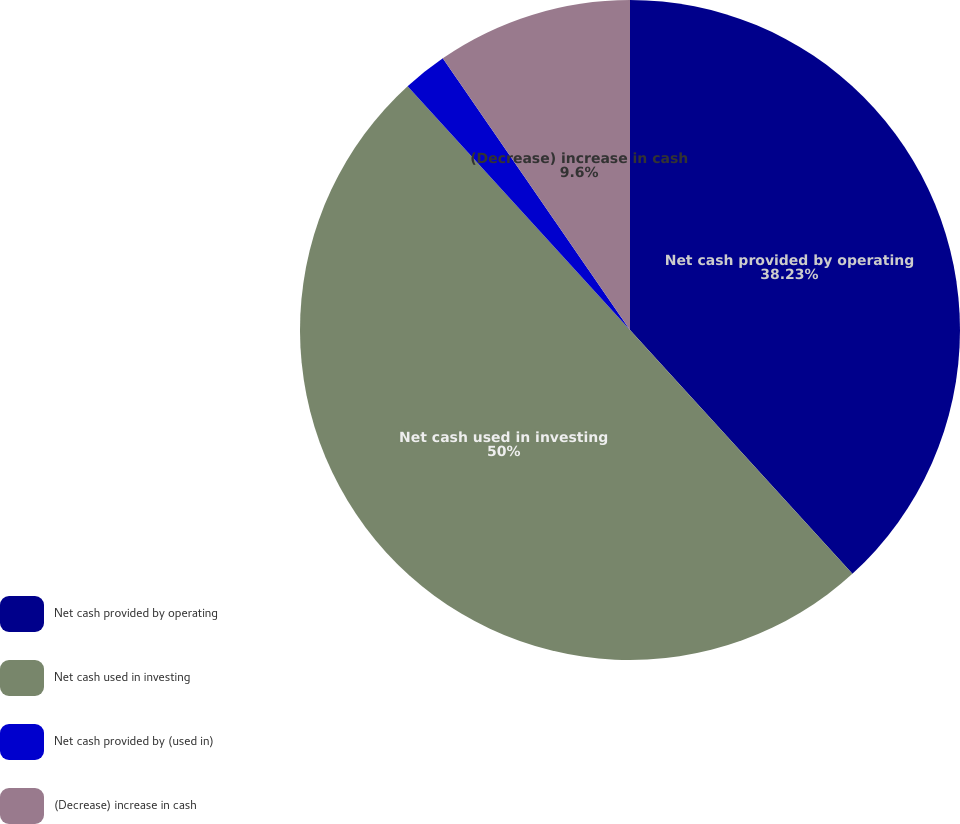Convert chart. <chart><loc_0><loc_0><loc_500><loc_500><pie_chart><fcel>Net cash provided by operating<fcel>Net cash used in investing<fcel>Net cash provided by (used in)<fcel>(Decrease) increase in cash<nl><fcel>38.23%<fcel>50.0%<fcel>2.17%<fcel>9.6%<nl></chart> 